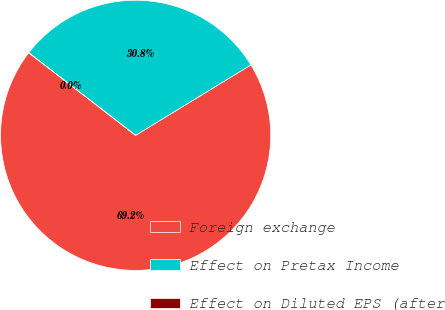<chart> <loc_0><loc_0><loc_500><loc_500><pie_chart><fcel>Foreign exchange<fcel>Effect on Pretax Income<fcel>Effect on Diluted EPS (after<nl><fcel>69.2%<fcel>30.8%<fcel>0.0%<nl></chart> 